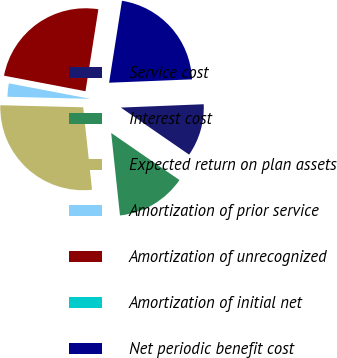Convert chart to OTSL. <chart><loc_0><loc_0><loc_500><loc_500><pie_chart><fcel>Service cost<fcel>Interest cost<fcel>Expected return on plan assets<fcel>Amortization of prior service<fcel>Amortization of unrecognized<fcel>Amortization of initial net<fcel>Net periodic benefit cost<nl><fcel>10.25%<fcel>13.7%<fcel>27.09%<fcel>2.6%<fcel>24.48%<fcel>0.0%<fcel>21.88%<nl></chart> 